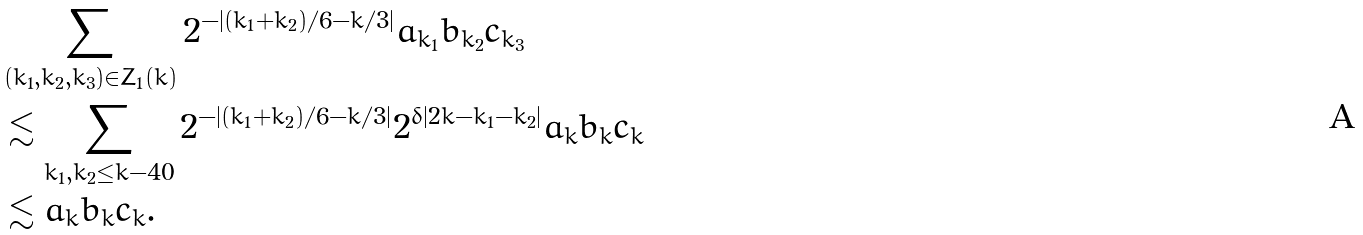<formula> <loc_0><loc_0><loc_500><loc_500>& \sum _ { ( k _ { 1 } , k _ { 2 } , k _ { 3 } ) \in Z _ { 1 } ( k ) } 2 ^ { - | ( k _ { 1 } + k _ { 2 } ) / 6 - k / 3 | } a _ { k _ { 1 } } b _ { k _ { 2 } } c _ { k _ { 3 } } \\ & \lesssim \sum _ { k _ { 1 } , k _ { 2 } \leq k - 4 0 } 2 ^ { - | ( k _ { 1 } + k _ { 2 } ) / 6 - k / 3 | } 2 ^ { \delta | 2 k - k _ { 1 } - k _ { 2 } | } a _ { k } b _ { k } c _ { k } \\ & \lesssim a _ { k } b _ { k } c _ { k } .</formula> 